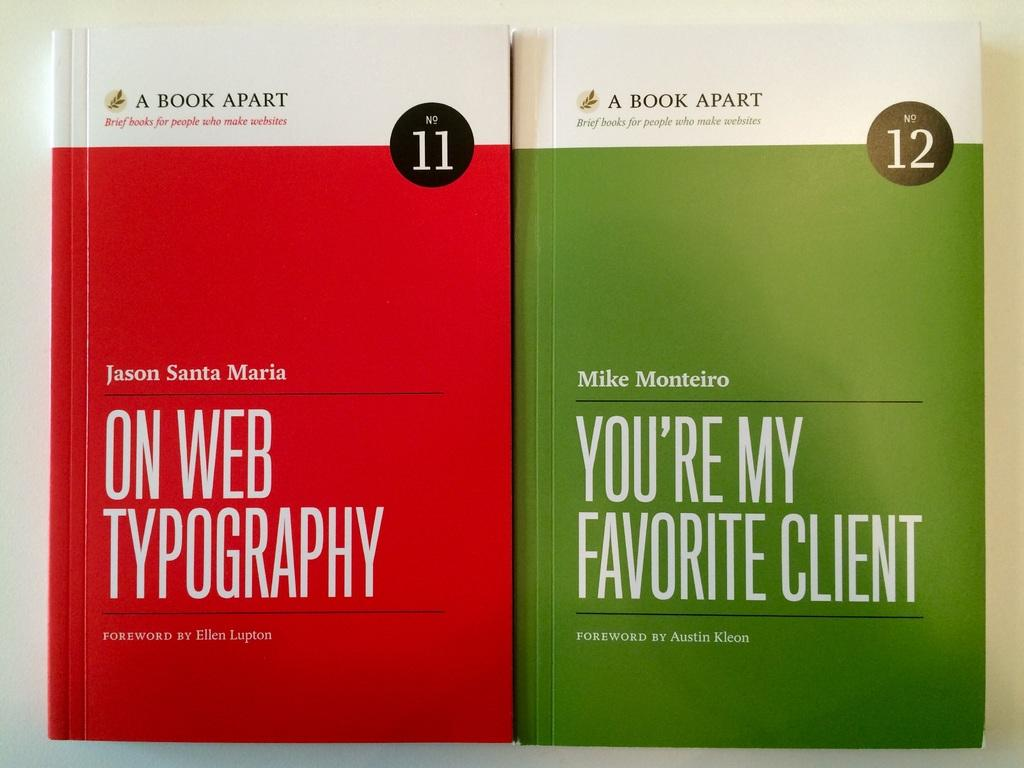<image>
Share a concise interpretation of the image provided. Two books with different colored covers reading ON WEB TYPOGRAPHY and YOU'RE MY FAVORITE CLIENT. 